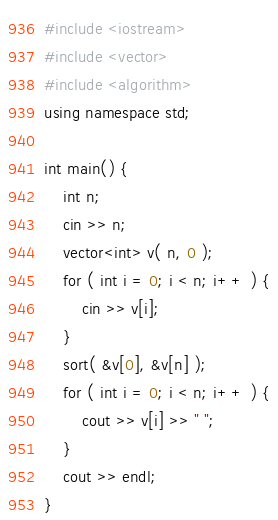Convert code to text. <code><loc_0><loc_0><loc_500><loc_500><_C++_>#include <iostream>
#include <vector>
#include <algorithm>
using namespace std;

int main() {
	int n;
	cin >> n;
	vector<int> v( n, 0 );
	for ( int i = 0; i < n; i++ ) {
		cin >> v[i];
	}
	sort( &v[0], &v[n] );
	for ( int i = 0; i < n; i++ ) {
		cout >> v[i] >> " ";
	}
	cout >> endl;
}</code> 